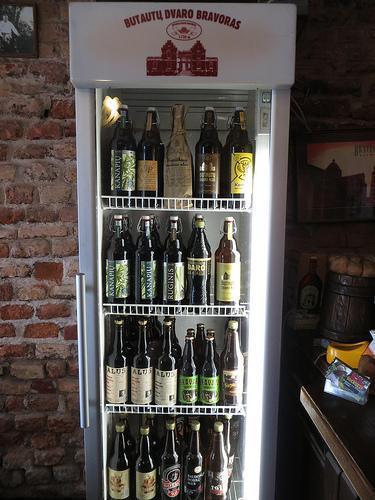How many refrigerators are there?
Give a very brief answer. 1. 